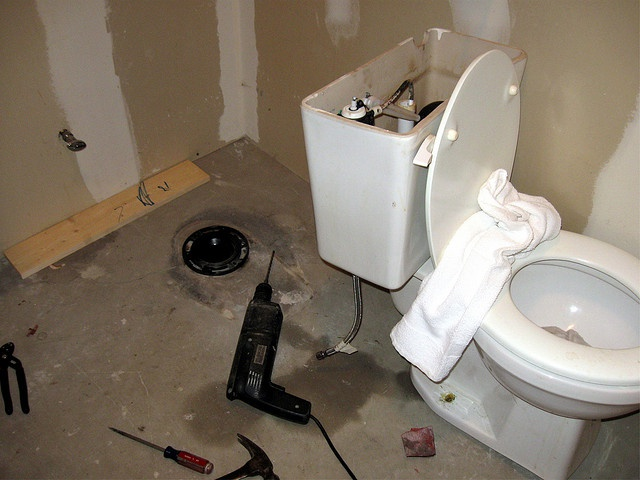Describe the objects in this image and their specific colors. I can see a toilet in gray, lightgray, and darkgray tones in this image. 